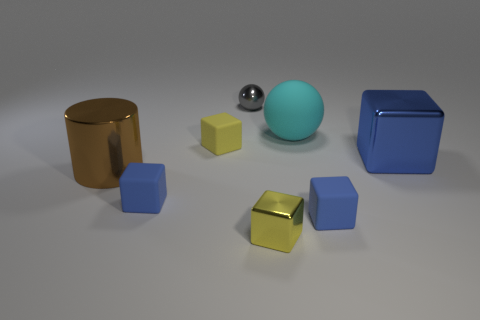Subtract all gray cylinders. How many yellow blocks are left? 2 Subtract all yellow shiny blocks. How many blocks are left? 4 Subtract all yellow cubes. How many cubes are left? 3 Subtract 2 cubes. How many cubes are left? 3 Add 2 balls. How many objects exist? 10 Subtract all cylinders. How many objects are left? 7 Subtract all red blocks. Subtract all green cylinders. How many blocks are left? 5 Add 7 big blocks. How many big blocks exist? 8 Subtract 0 green cylinders. How many objects are left? 8 Subtract all large brown metallic objects. Subtract all shiny cylinders. How many objects are left? 6 